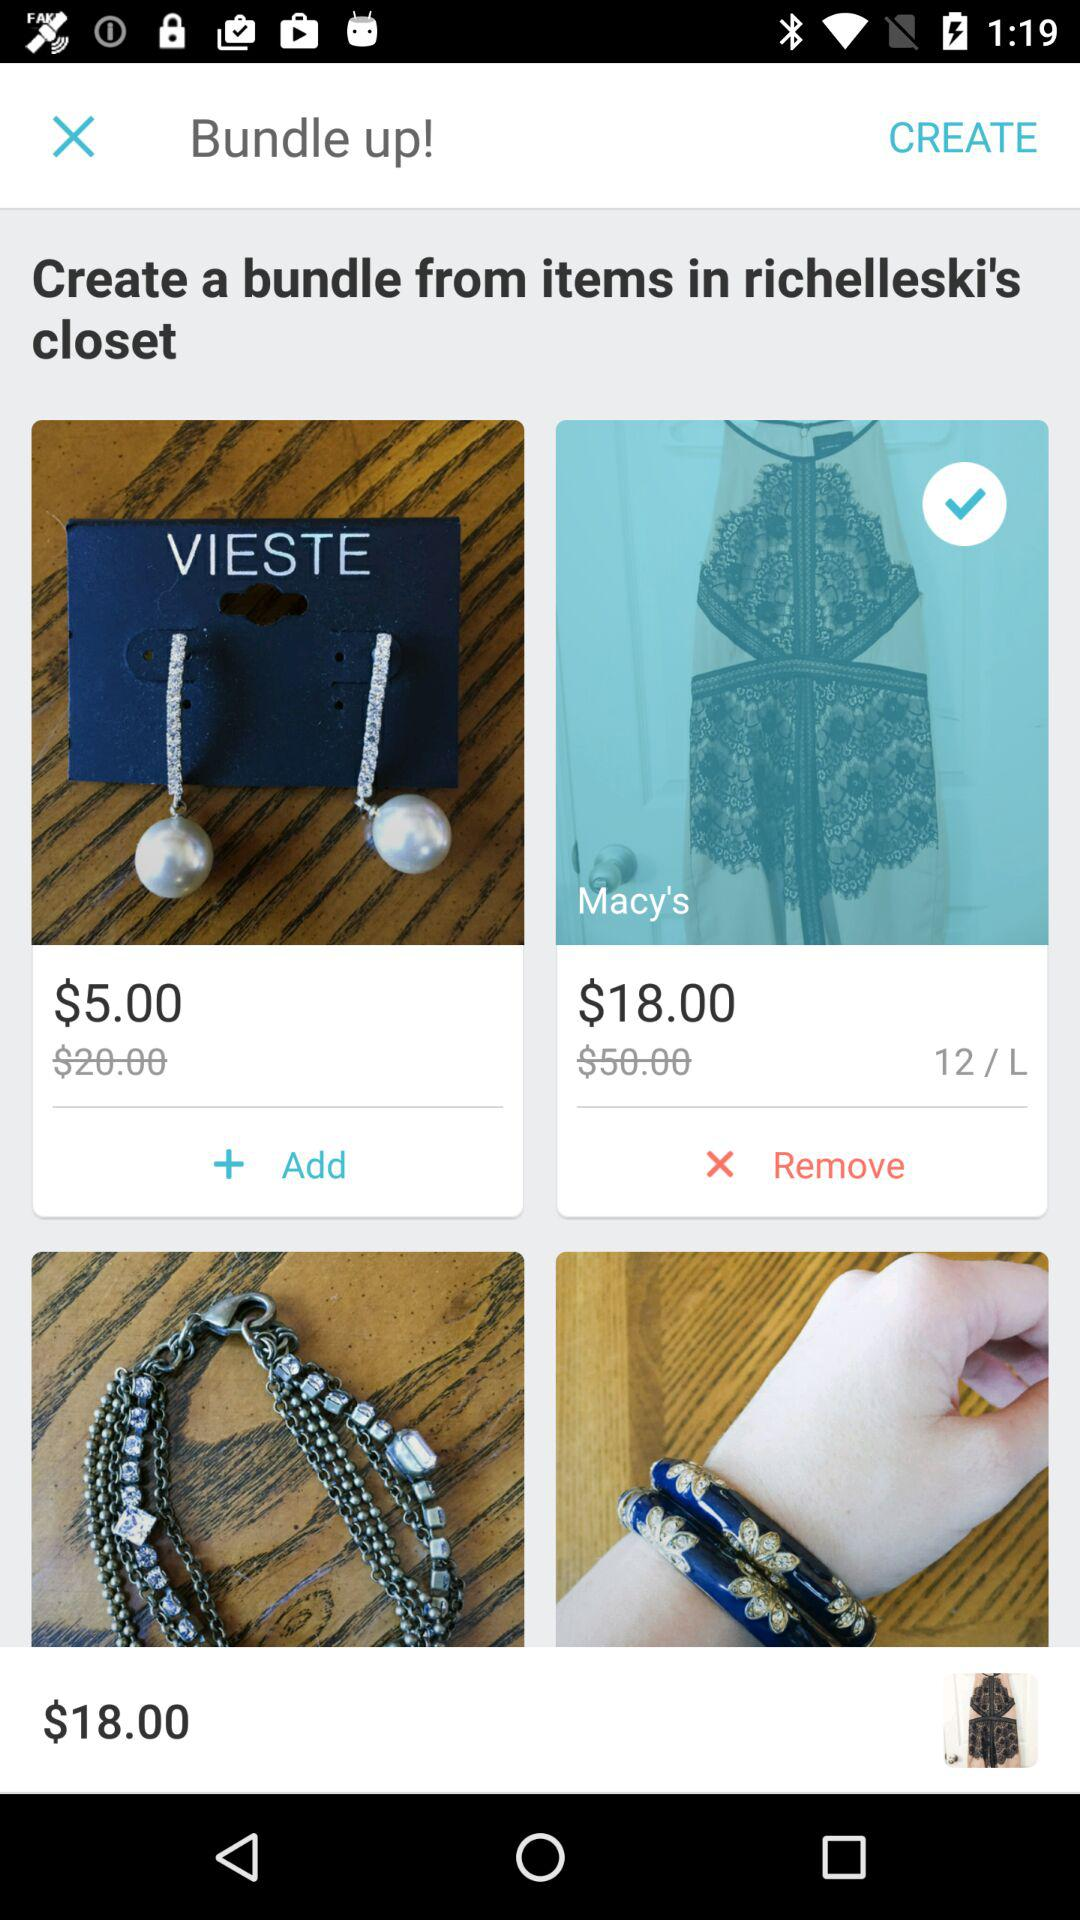What is the selected item?
When the provided information is insufficient, respond with <no answer>. <no answer> 